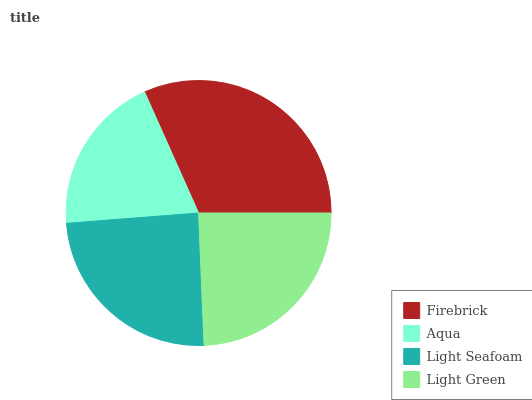Is Aqua the minimum?
Answer yes or no. Yes. Is Firebrick the maximum?
Answer yes or no. Yes. Is Light Seafoam the minimum?
Answer yes or no. No. Is Light Seafoam the maximum?
Answer yes or no. No. Is Light Seafoam greater than Aqua?
Answer yes or no. Yes. Is Aqua less than Light Seafoam?
Answer yes or no. Yes. Is Aqua greater than Light Seafoam?
Answer yes or no. No. Is Light Seafoam less than Aqua?
Answer yes or no. No. Is Light Seafoam the high median?
Answer yes or no. Yes. Is Light Green the low median?
Answer yes or no. Yes. Is Light Green the high median?
Answer yes or no. No. Is Light Seafoam the low median?
Answer yes or no. No. 